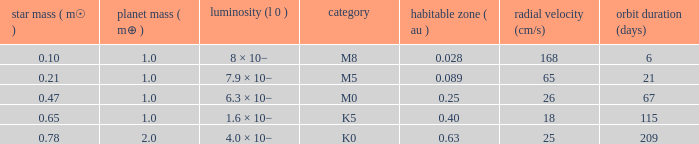What is the highest planetary mass having an RV (cm/s) of 65 and a Period (days) less than 21? None. 